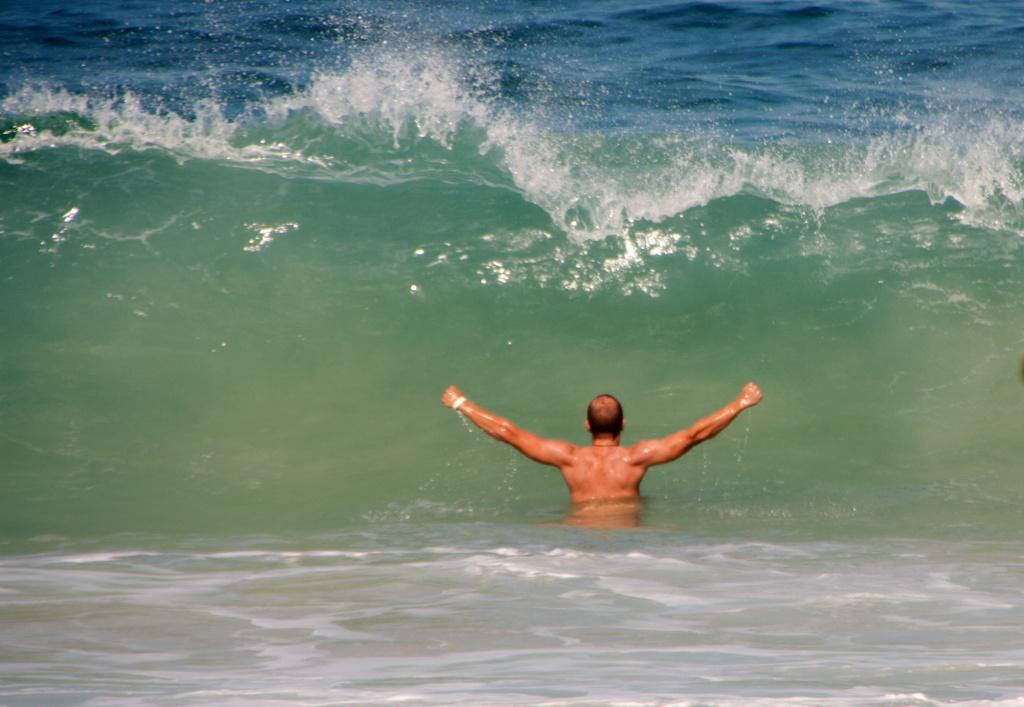Please provide a concise description of this image. In this picture there is a man in the center of the image, in the water and there is water around the area of the image. 